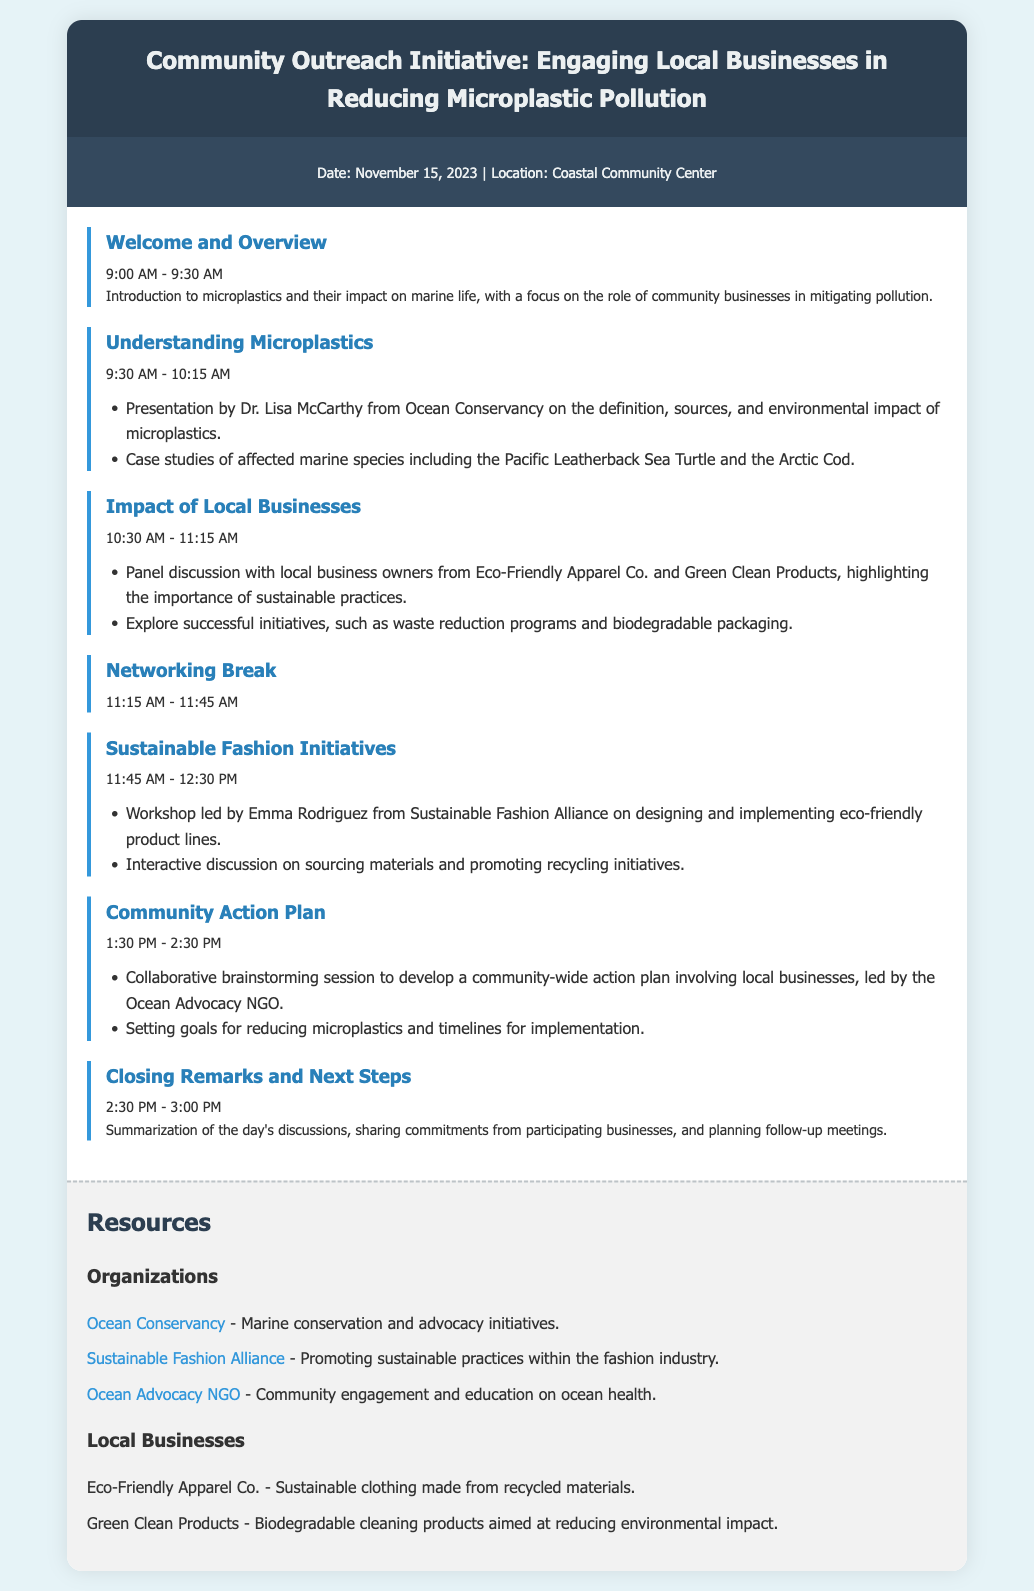What is the date of the event? The date of the event is specified in the document's event information section.
Answer: November 15, 2023 Who will present on the definition and sources of microplastics? The document includes a session discussing microplastics and credits Dr. Lisa McCarthy for the presentation.
Answer: Dr. Lisa McCarthy What time does the networking break start? The document lists the schedule and the networking break time.
Answer: 11:15 AM Which organization is focused on sustainable practices within the fashion industry? The resources section of the document lists organizations, one of which promotes sustainable fashion.
Answer: Sustainable Fashion Alliance What is the main goal of the Community Action Plan session? The session description reveals the objectives of community interaction and planning regarding microplastics.
Answer: Developing a community-wide action plan What businesses are highlighted in the panel discussion? The document notes two local business names involved in the discussion on sustainable practices.
Answer: Eco-Friendly Apparel Co. and Green Clean Products What type of products does Green Clean Products offer? The resources section provides information on the type of products sold by the featured local business.
Answer: Biodegradable cleaning products What follows the Closing Remarks? The agenda mentions what is discussed just after the closing remarks.
Answer: Planning follow-up meetings 